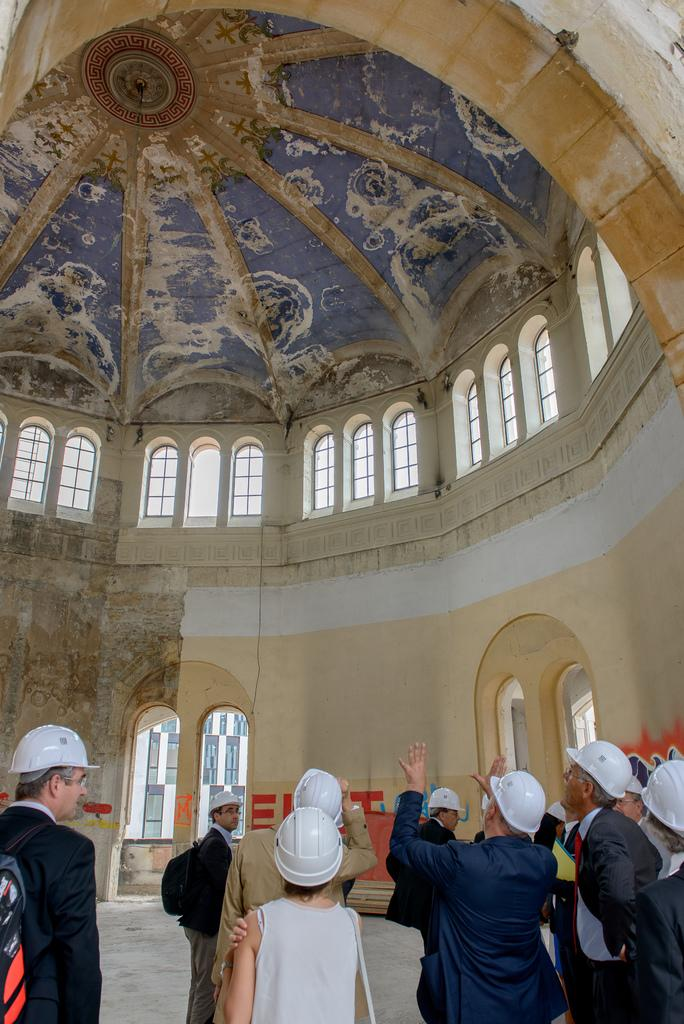What can be seen in the image? There are people standing in the image. What are the people wearing? The people are wearing helmets. What is visible in the background of the image? There is a wall and windows in the background of the image. What architectural feature is visible at the top of the image? There is a dome visible at the top of the image. What type of vacation is the group planning based on the image? There is no information in the image to suggest that the group is planning a vacation. What knowledge can be gained from the image about the people's expertise? The image does not provide any information about the people's expertise or knowledge. 